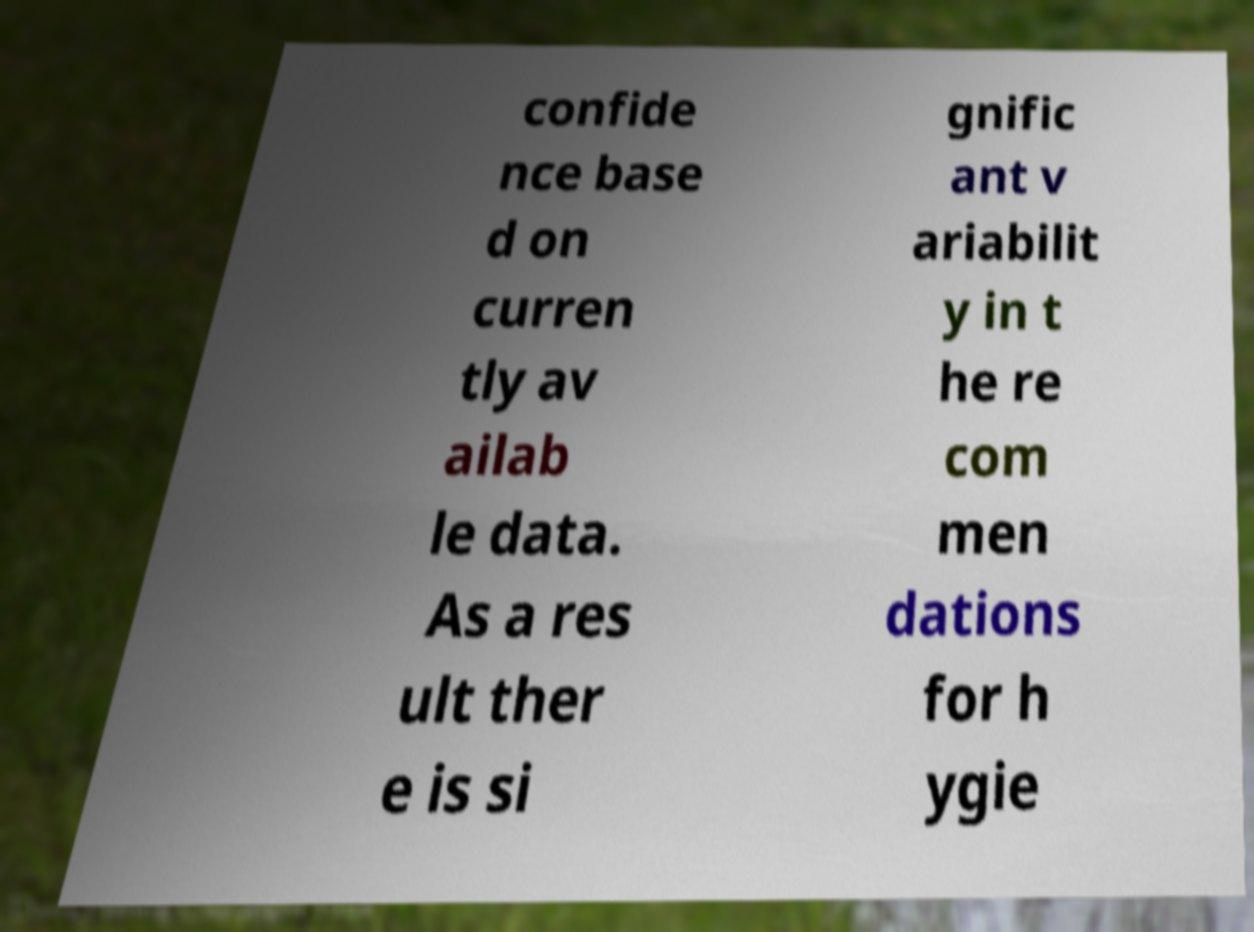What messages or text are displayed in this image? I need them in a readable, typed format. confide nce base d on curren tly av ailab le data. As a res ult ther e is si gnific ant v ariabilit y in t he re com men dations for h ygie 